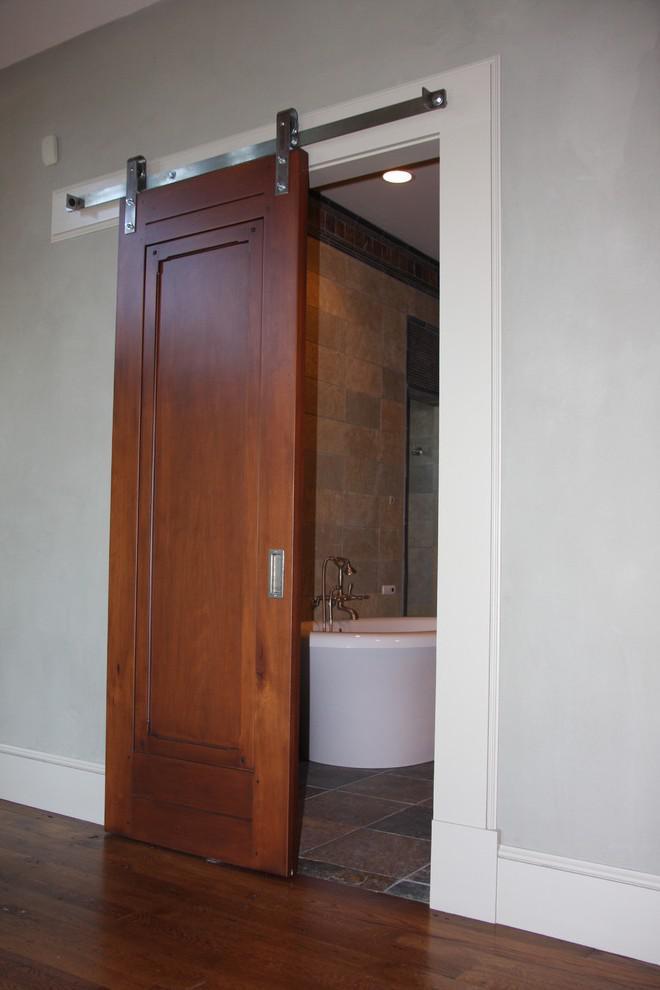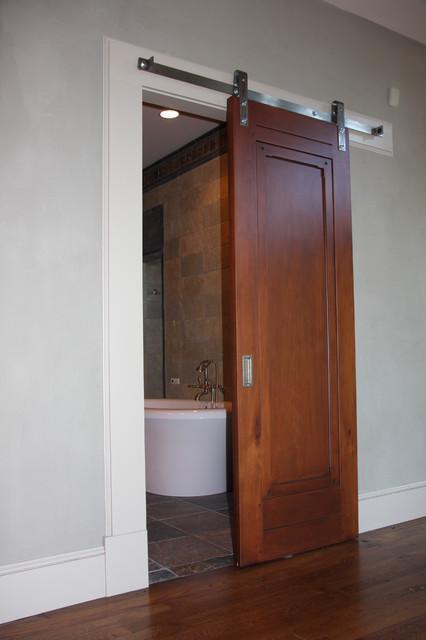The first image is the image on the left, the second image is the image on the right. Considering the images on both sides, is "The left and right image contains the same number of hanging doors with at least one white wooden door." valid? Answer yes or no. No. The first image is the image on the left, the second image is the image on the right. Analyze the images presented: Is the assertion "There are multiple doors in one image." valid? Answer yes or no. No. 